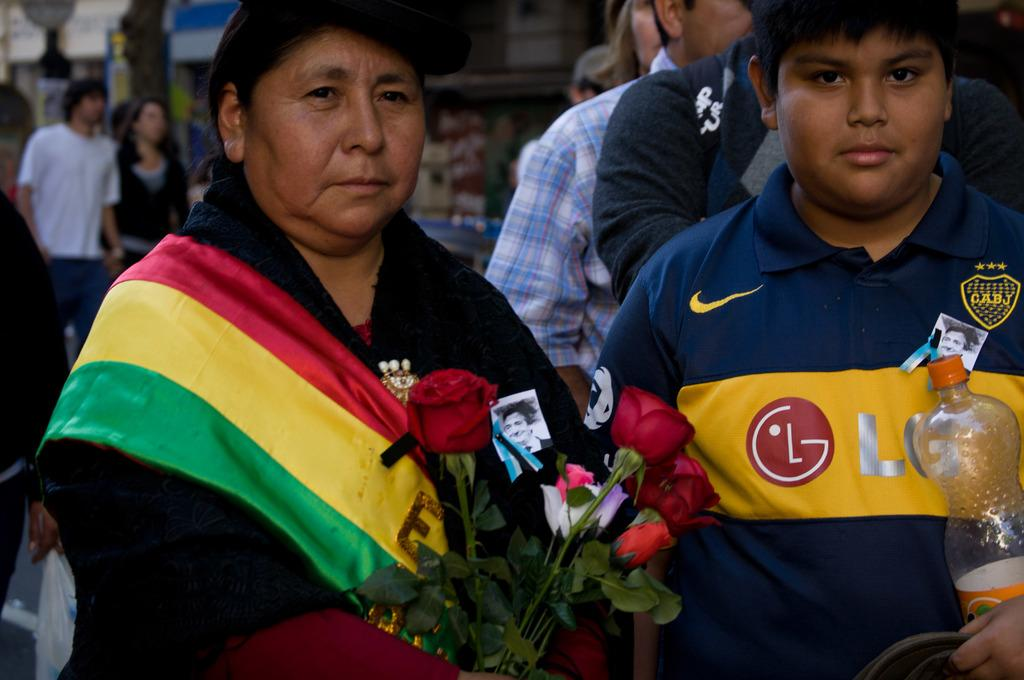How many people can be seen in the front of the image? There are two people standing in the front of the image. What are the two people holding in their hands? The two people are holding roses in their hands. What else can be seen in the image besides the two people? There is a bottle present in the image. What is happening in the background of the image? There is a group of people walking in the background. Can you describe the setting where the group of people are walking? The group of people are walking on a road in the background. What type of cook is featured in the image? There is no cook present in the image. What is the plot of the story unfolding in the image? There is no story or plot depicted in the image; it simply shows two people holding roses, a bottle, and a group of people walking in the background. 